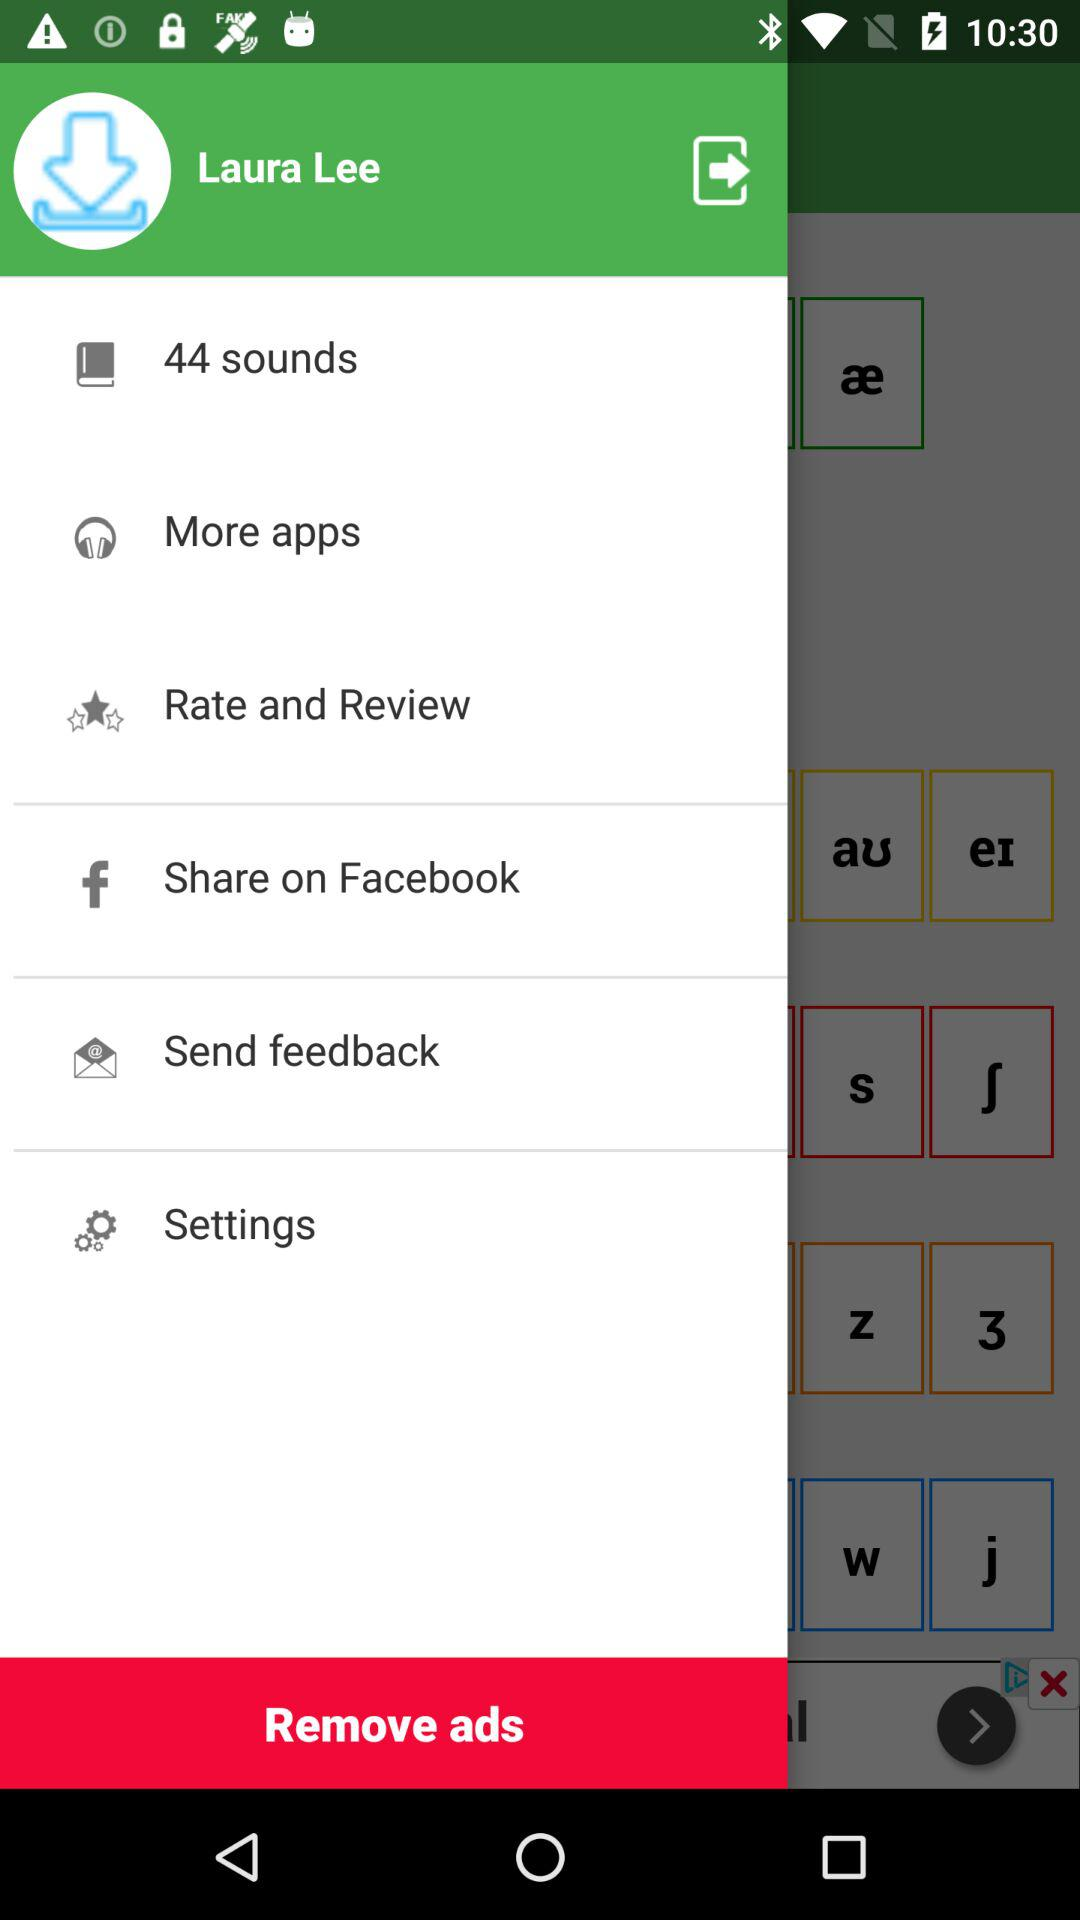What is the name of the user? The name of the user is Laura Lee. 